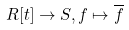Convert formula to latex. <formula><loc_0><loc_0><loc_500><loc_500>R [ t ] \rightarrow S , f \mapsto \overline { f }</formula> 